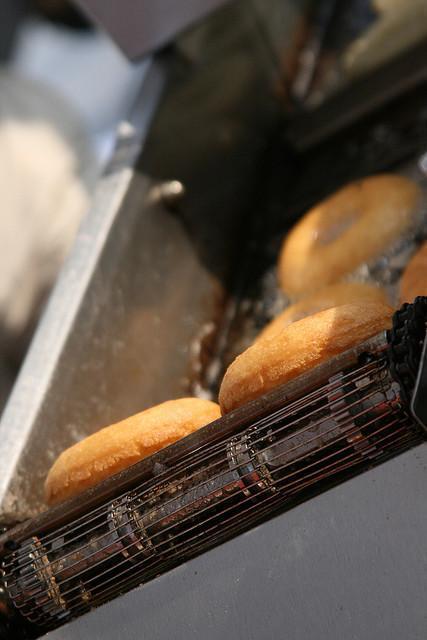How many donuts can be seen?
Give a very brief answer. 3. 